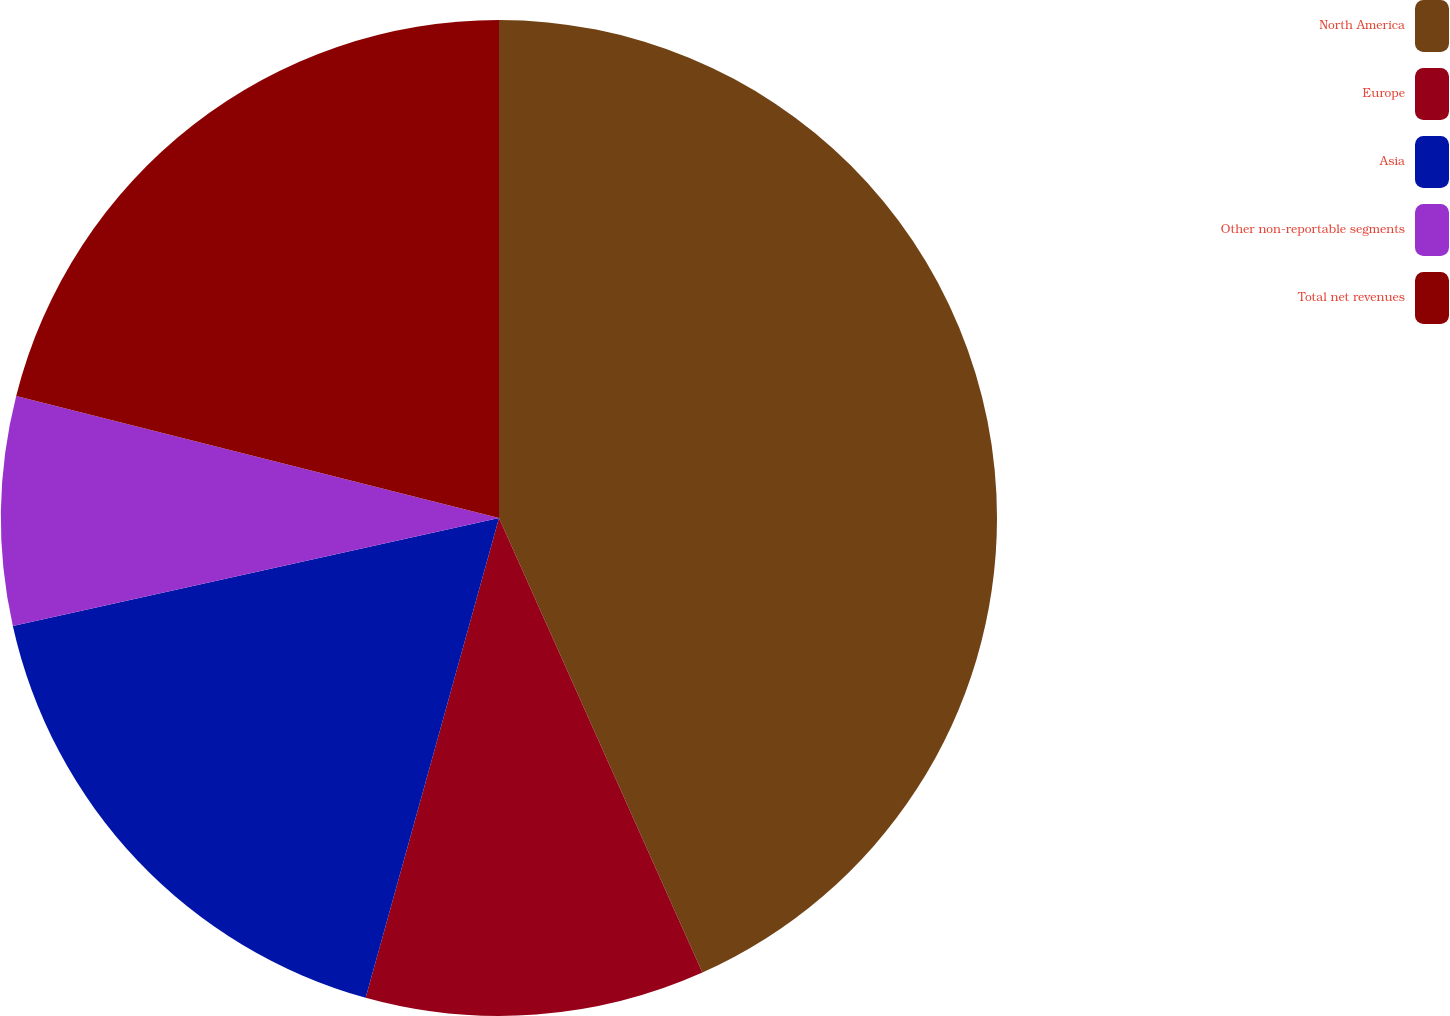Convert chart. <chart><loc_0><loc_0><loc_500><loc_500><pie_chart><fcel>North America<fcel>Europe<fcel>Asia<fcel>Other non-reportable segments<fcel>Total net revenues<nl><fcel>43.31%<fcel>11.01%<fcel>17.21%<fcel>7.42%<fcel>21.06%<nl></chart> 